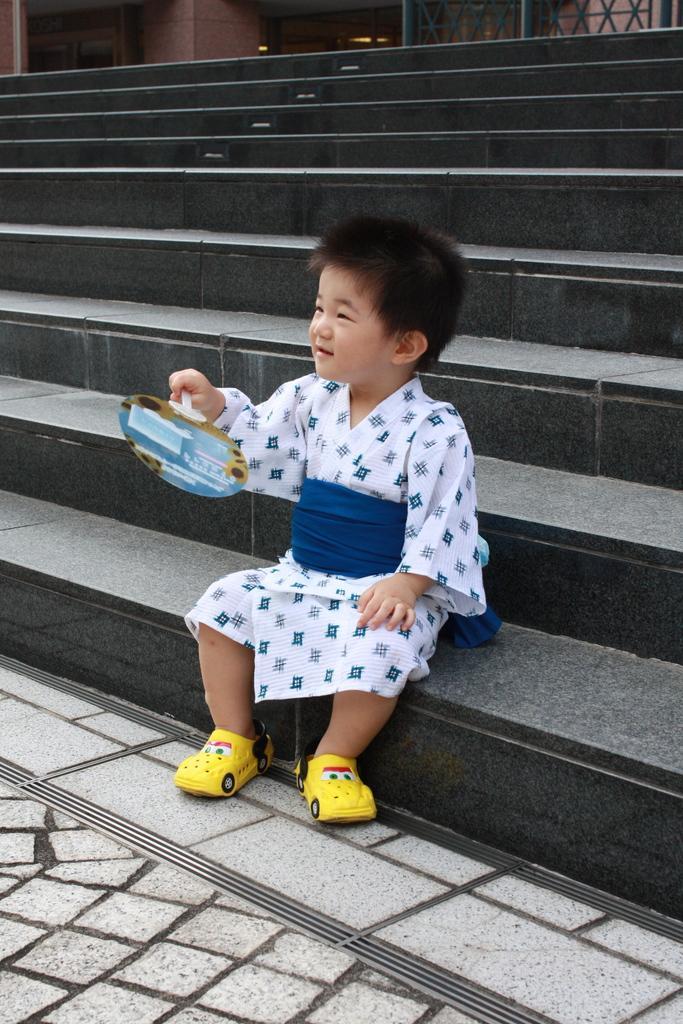Describe this image in one or two sentences. In this image there is a kid sitting on the stairs of a building and holding an object in his hand. 